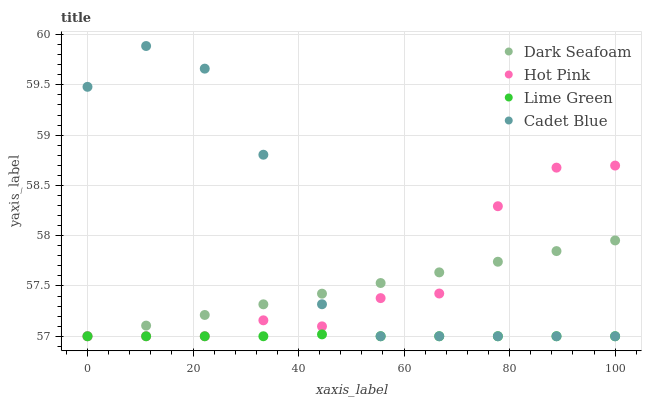Does Lime Green have the minimum area under the curve?
Answer yes or no. Yes. Does Cadet Blue have the maximum area under the curve?
Answer yes or no. Yes. Does Dark Seafoam have the minimum area under the curve?
Answer yes or no. No. Does Dark Seafoam have the maximum area under the curve?
Answer yes or no. No. Is Dark Seafoam the smoothest?
Answer yes or no. Yes. Is Cadet Blue the roughest?
Answer yes or no. Yes. Is Hot Pink the smoothest?
Answer yes or no. No. Is Hot Pink the roughest?
Answer yes or no. No. Does Cadet Blue have the lowest value?
Answer yes or no. Yes. Does Cadet Blue have the highest value?
Answer yes or no. Yes. Does Dark Seafoam have the highest value?
Answer yes or no. No. Does Hot Pink intersect Dark Seafoam?
Answer yes or no. Yes. Is Hot Pink less than Dark Seafoam?
Answer yes or no. No. Is Hot Pink greater than Dark Seafoam?
Answer yes or no. No. 